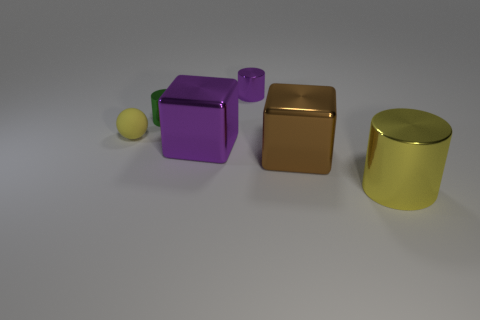What size is the matte sphere that is the same color as the big cylinder?
Ensure brevity in your answer.  Small. Do the big purple block and the cylinder that is behind the green metal object have the same material?
Give a very brief answer. Yes. What color is the sphere?
Provide a succinct answer. Yellow. There is a yellow thing that is made of the same material as the big brown block; what size is it?
Offer a very short reply. Large. There is a yellow thing in front of the large cube to the right of the purple cylinder; what number of small metal cylinders are behind it?
Ensure brevity in your answer.  2. There is a big metal cylinder; is it the same color as the tiny thing on the left side of the green shiny thing?
Make the answer very short. Yes. What shape is the metallic object that is the same color as the small matte sphere?
Offer a terse response. Cylinder. There is a thing that is left of the tiny metallic cylinder on the left side of the tiny cylinder that is on the right side of the big purple shiny block; what is its material?
Offer a terse response. Rubber. Is the shape of the purple thing that is in front of the tiny yellow matte ball the same as  the small green metallic object?
Offer a terse response. No. There is a purple object that is on the left side of the tiny purple metal cylinder; what is its material?
Your response must be concise. Metal. 